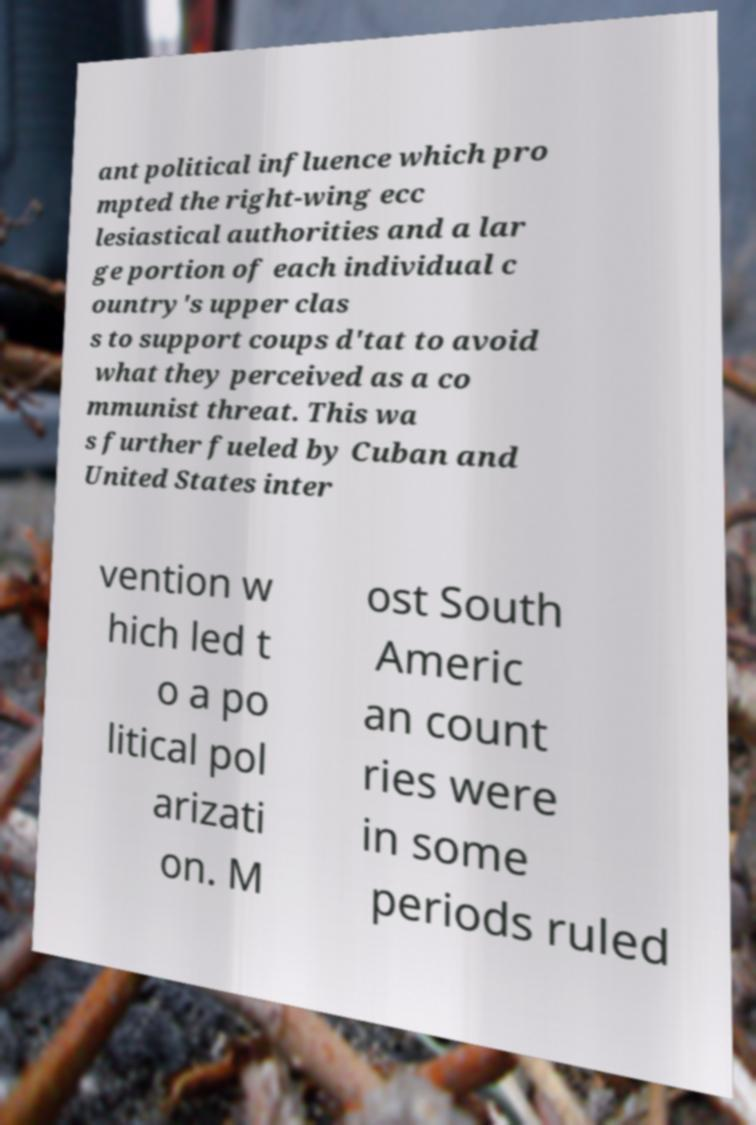Please read and relay the text visible in this image. What does it say? ant political influence which pro mpted the right-wing ecc lesiastical authorities and a lar ge portion of each individual c ountry's upper clas s to support coups d'tat to avoid what they perceived as a co mmunist threat. This wa s further fueled by Cuban and United States inter vention w hich led t o a po litical pol arizati on. M ost South Americ an count ries were in some periods ruled 